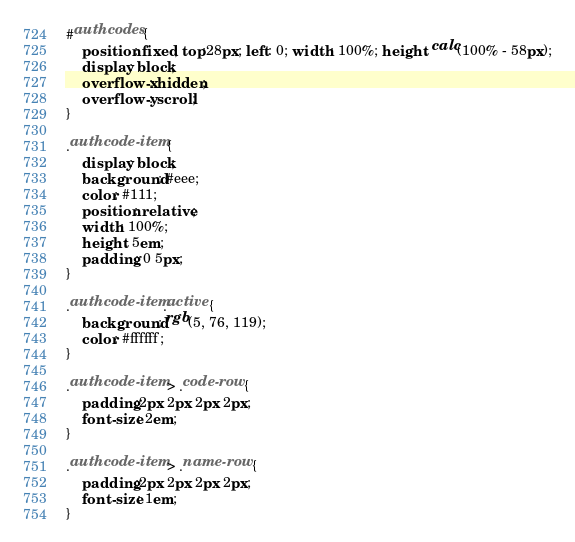Convert code to text. <code><loc_0><loc_0><loc_500><loc_500><_CSS_>
#authcodes {
    position: fixed; top:28px; left: 0; width: 100%; height: calc(100% - 58px);
    display: block;
    overflow-x: hidden;
    overflow-y: scroll;
}

.authcode-item {
    display: block;
    background: #eee;
    color: #111;
    position: relative;
    width: 100%;
    height: 5em;
    padding: 0 5px;
}

.authcode-item.active {
    background: rgb(5, 76, 119);
    color: #ffffff;
}

.authcode-item > .code-row {
    padding:2px 2px 2px 2px;
    font-size: 2em;
}

.authcode-item > .name-row {
    padding:2px 2px 2px 2px;
    font-size: 1em;
}
</code> 